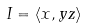Convert formula to latex. <formula><loc_0><loc_0><loc_500><loc_500>I = \langle x , y z \rangle</formula> 